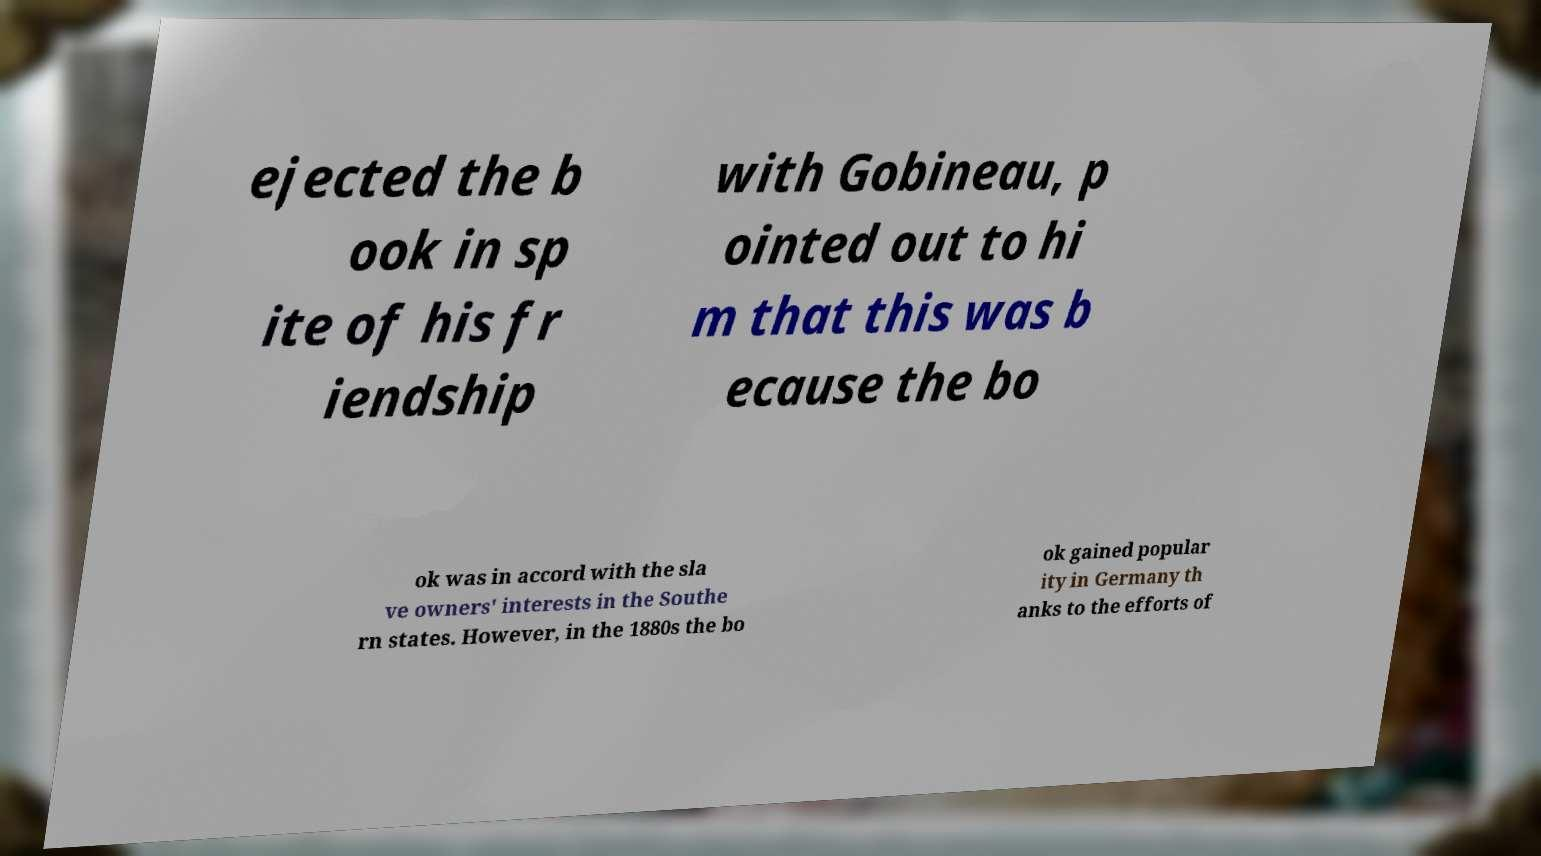Please identify and transcribe the text found in this image. ejected the b ook in sp ite of his fr iendship with Gobineau, p ointed out to hi m that this was b ecause the bo ok was in accord with the sla ve owners' interests in the Southe rn states. However, in the 1880s the bo ok gained popular ity in Germany th anks to the efforts of 